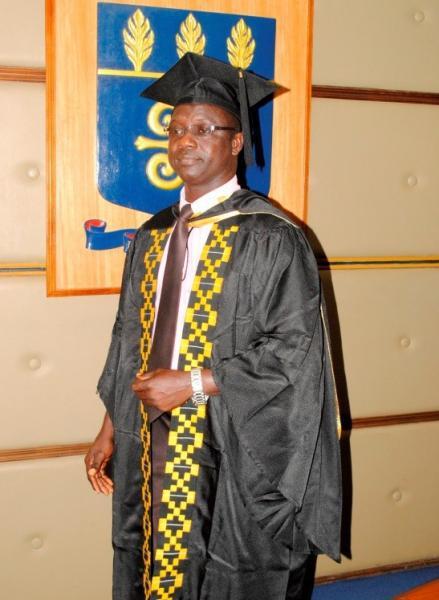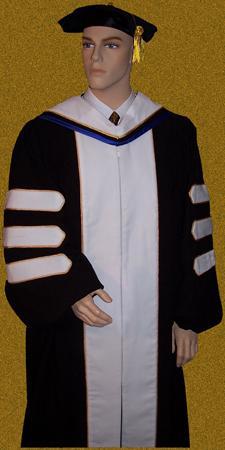The first image is the image on the left, the second image is the image on the right. Considering the images on both sides, is "The right image contains a mannequin wearing a graduation gown." valid? Answer yes or no. Yes. The first image is the image on the left, the second image is the image on the right. Analyze the images presented: Is the assertion "At least one image shows a mannequin modeling a graduation robe with three stripes on each sleeve." valid? Answer yes or no. Yes. 